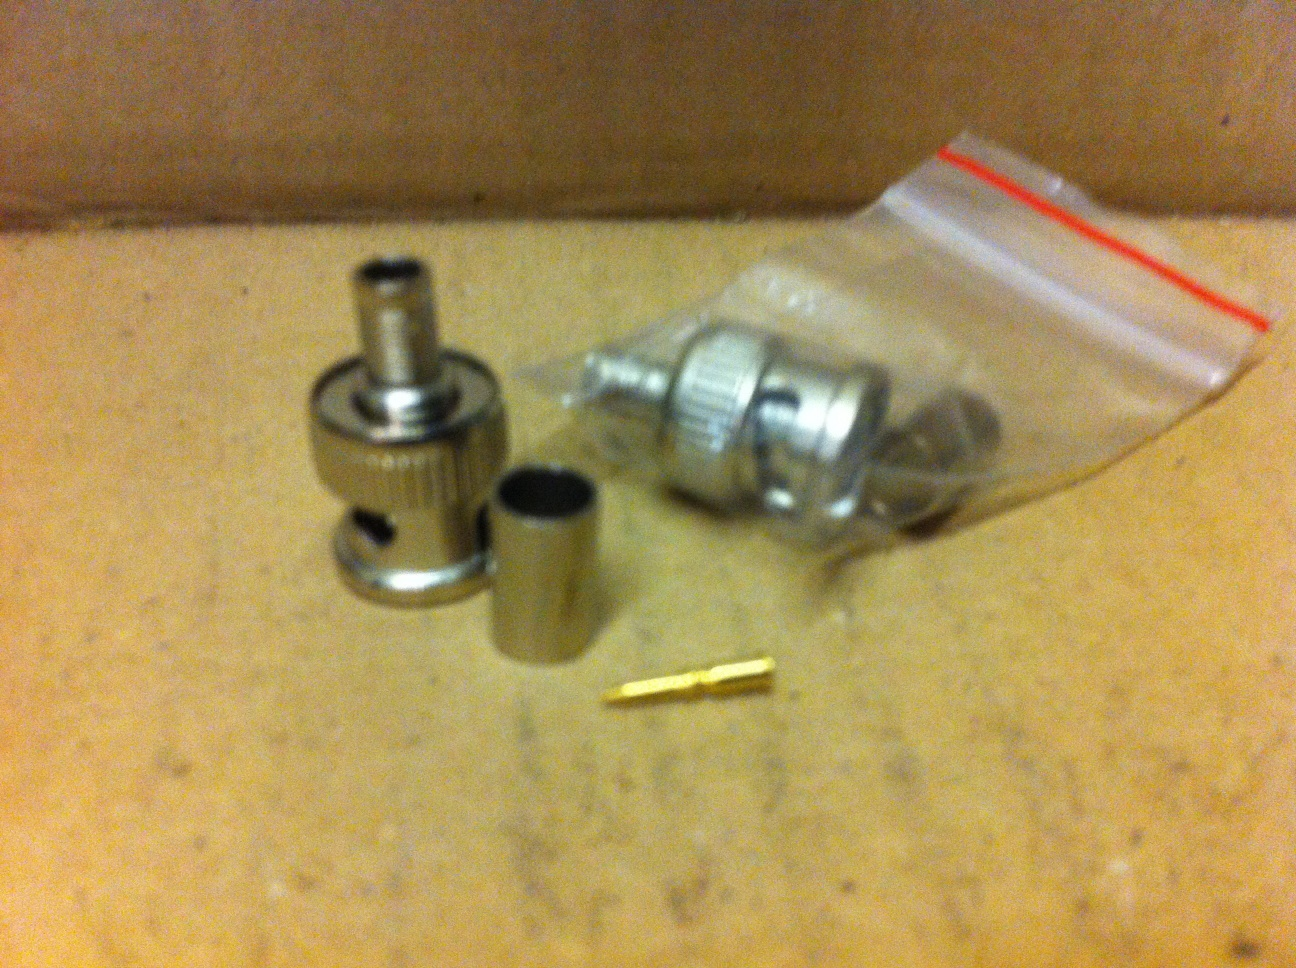How would you assemble these parts? To assemble these parts, follow these general steps: 
1. Strip the coaxial cable to expose the inner conductor and the braided shielding. 
2. Slide the barrel sleeve over the cable. 
3. Insert the inner conductor into the brass pin and crimp it securely. 
4. Push the braided shielding back over the stripped part of the cable. 
5. Insert the cable with the crimped pin into the connector housing. 
6. Slide the barrel sleeve up and crimp it into place on the housing to secure the connection. 